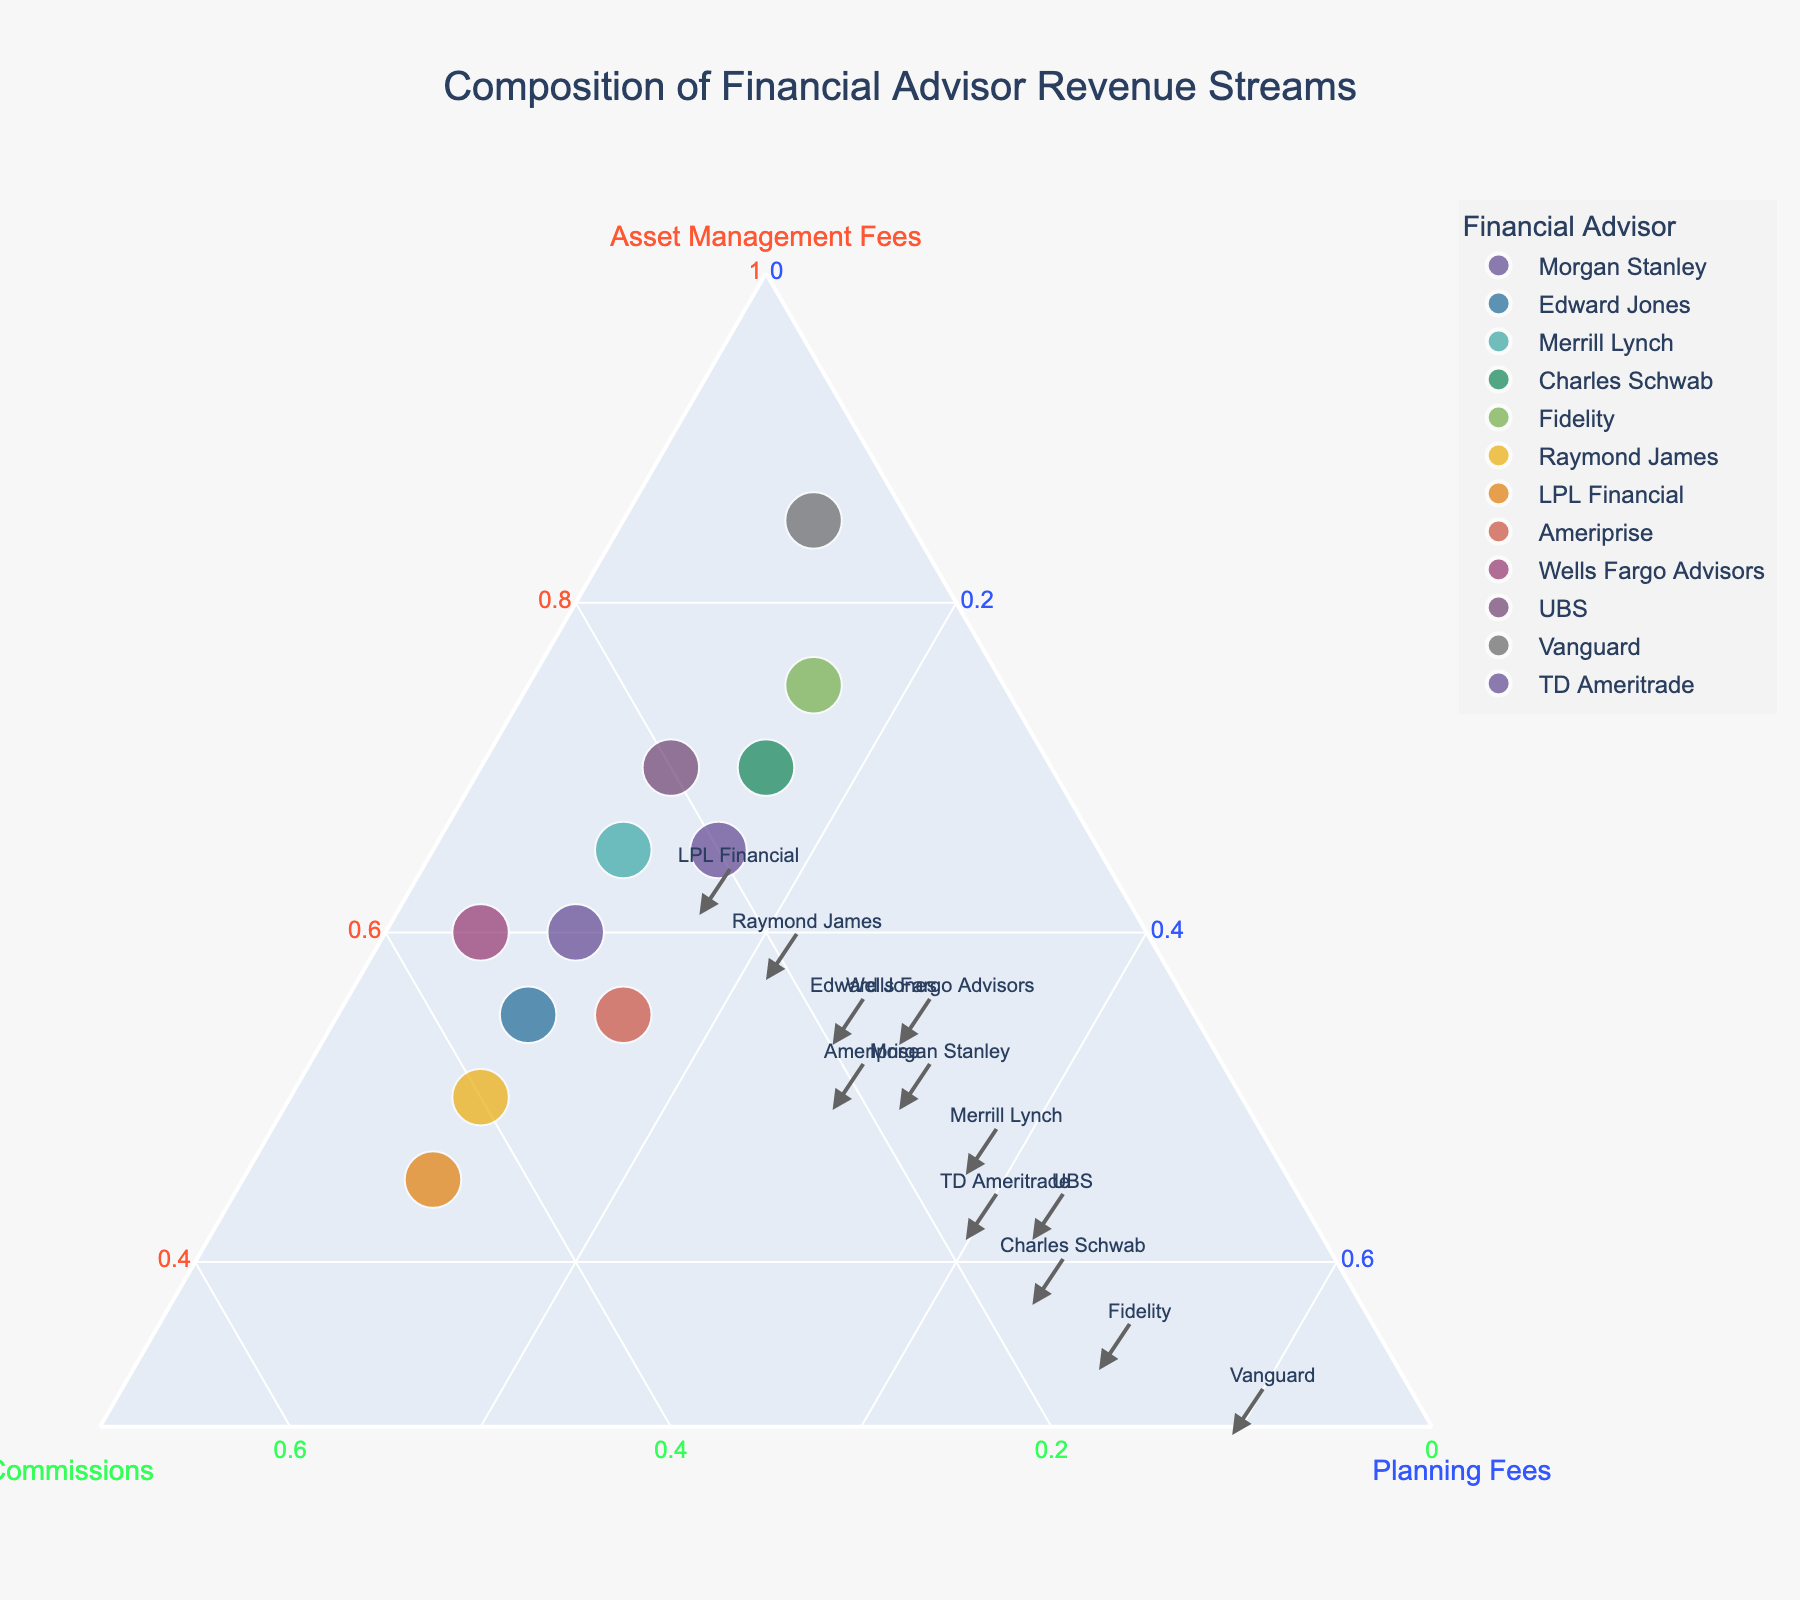Which advisor has the highest proportion of revenue from asset management fees? By looking at the ternary plot, identify the point closest to the vertex labeled "Asset Management Fees." The point for Vanguard is the closest to this vertex.
Answer: Vanguard Which advisor has equal proportions of revenue from commissions and planning fees? Identify the point that lies along the line bisecting the space between "Commissions" and "Planning Fees." The data label indicates LPL Financial is at that position.
Answer: LPL Financial What is the primary revenue stream for Edward Jones? Locate Edward Jones on the ternary plot and determine which axis value it is closest to. Edward Jones is closer to the "Asset Management Fees" axis, indicating it is its primary revenue stream.
Answer: Asset Management Fees How does Charles Schwab's revenue composition compare to UBS's revenue composition? Compare the positions of Charles Schwab and UBS on the ternary plot. Charles Schwab has a higher proportion of revenue from asset management fees and planning fees, but a lower proportion from commissions compared to UBS.
Answer: Charles Schwab has higher asset management fees and planning fees but lower commissions Which advisor has the lowest proportion of revenue from planning fees? Look at the points closest to the "Commissions" and "Asset Management Fees" axes and farthest away from "Planning Fees." Wells Fargo Advisors is nearest to this criteria.
Answer: Wells Fargo Advisors Among the advisors shown, which one has a more balanced revenue mix from all three streams? Search for the advisor whose point is closest to the center of the ternary plot. Ameriprise appears to have a more balanced distribution across the three revenue streams.
Answer: Ameriprise Which advisor has the highest identification as commissions in their revenue streams? Identify the point closest to the vertex labeled "Commissions." LPL Financial is closest to this point.
Answer: LPL Financial 